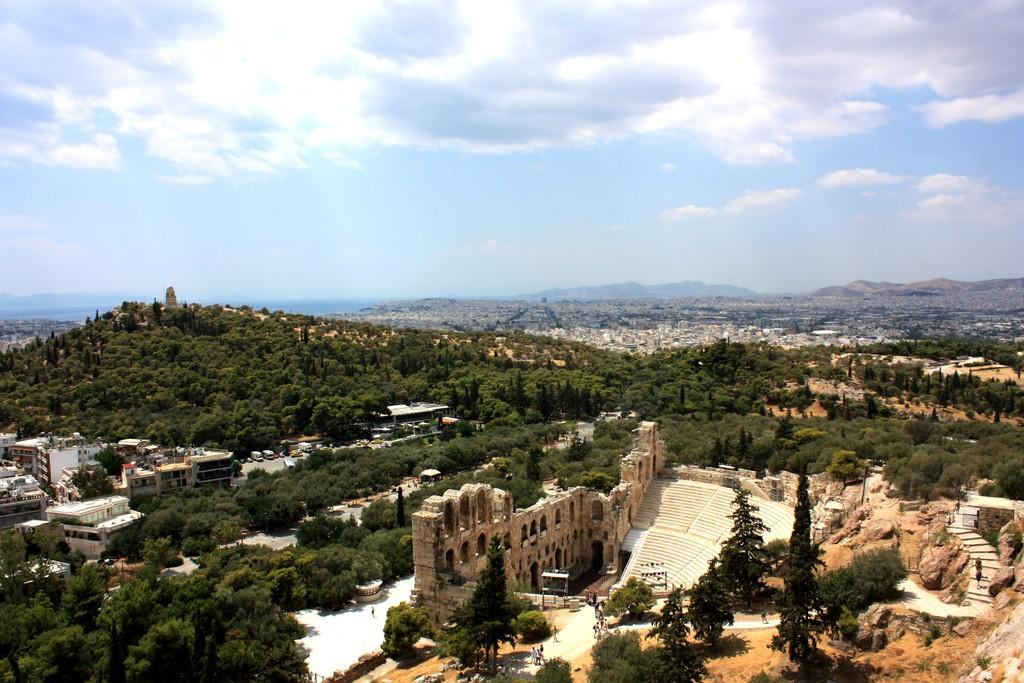What type of view is shown in the image? The image is an aerial view of a city. What can be seen in the foreground of the image? There are trees and buildings in the foreground of the image, along with visible architecture. What is visible in the background of the image? There are buildings, trees, and hills visible in the background of the image. What type of coil is used to paint the buildings in the image? There is no mention of a coil or painting in the image; it is a photograph of a city. How are the buildings in the image being used? The image does not provide information about the use of the buildings; it is a photograph of a city from an aerial view. 